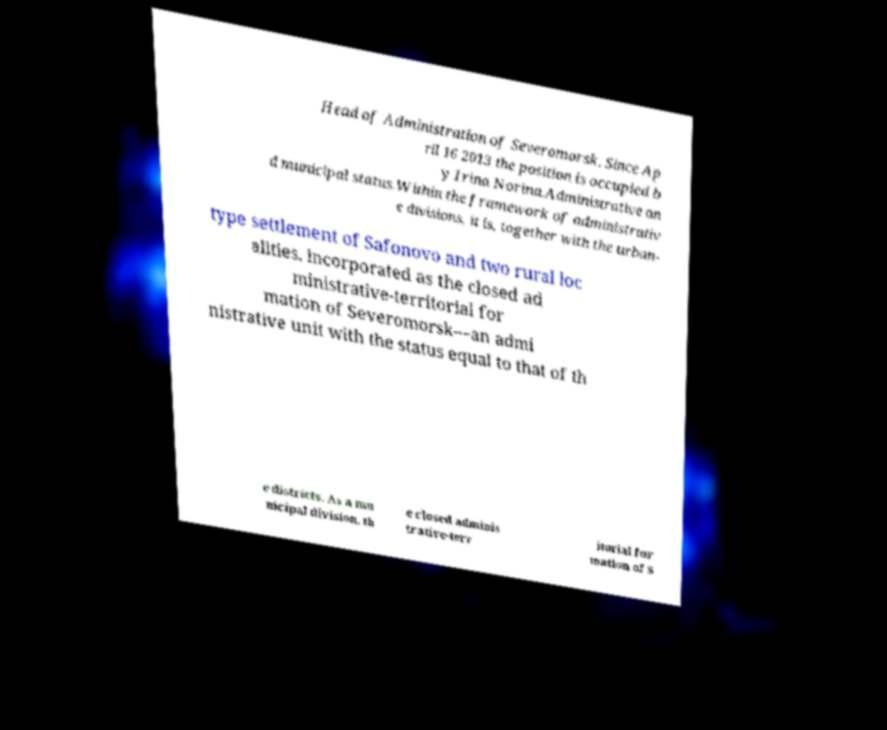What messages or text are displayed in this image? I need them in a readable, typed format. Head of Administration of Severomorsk. Since Ap ril 16 2013 the position is occupied b y Irina Norina.Administrative an d municipal status.Within the framework of administrativ e divisions, it is, together with the urban- type settlement of Safonovo and two rural loc alities, incorporated as the closed ad ministrative-territorial for mation of Severomorsk—an admi nistrative unit with the status equal to that of th e districts. As a mu nicipal division, th e closed adminis trative-terr itorial for mation of S 